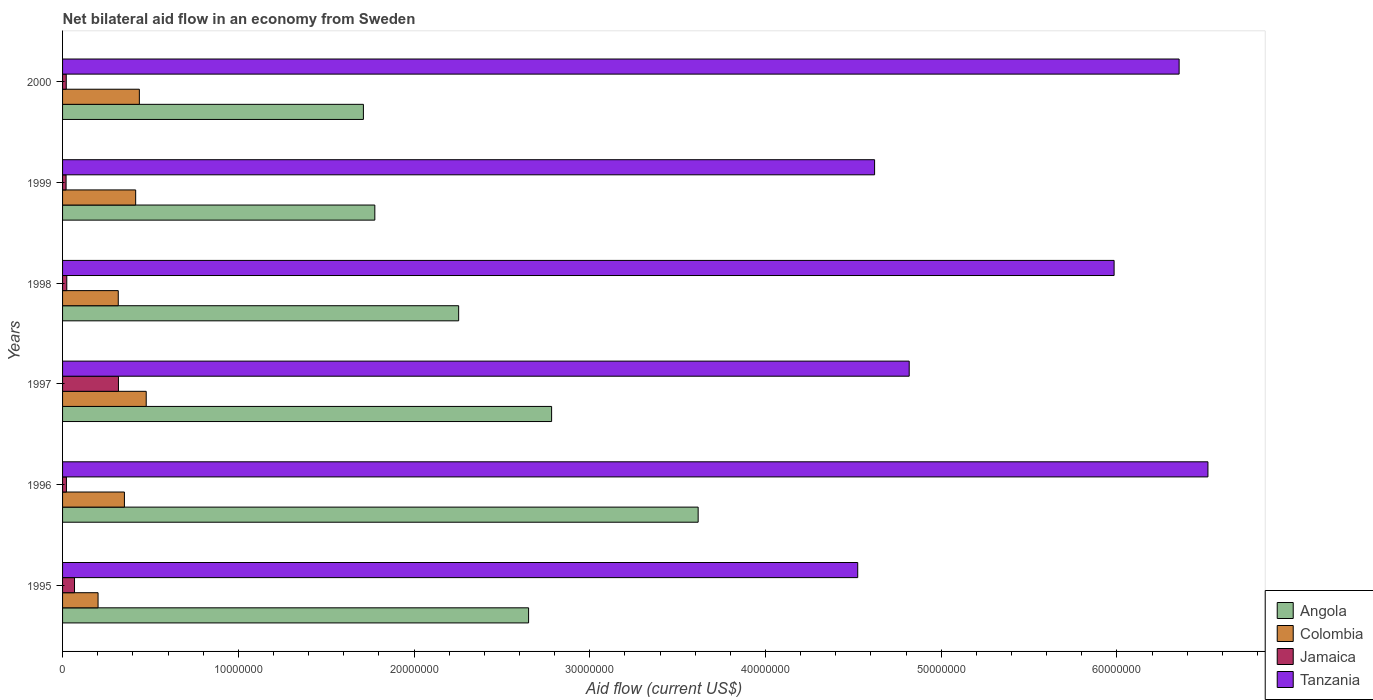Are the number of bars per tick equal to the number of legend labels?
Provide a succinct answer. Yes. Are the number of bars on each tick of the Y-axis equal?
Provide a succinct answer. Yes. What is the net bilateral aid flow in Angola in 2000?
Offer a terse response. 1.71e+07. Across all years, what is the maximum net bilateral aid flow in Angola?
Give a very brief answer. 3.62e+07. Across all years, what is the minimum net bilateral aid flow in Jamaica?
Offer a terse response. 2.00e+05. In which year was the net bilateral aid flow in Tanzania minimum?
Provide a short and direct response. 1995. What is the total net bilateral aid flow in Angola in the graph?
Make the answer very short. 1.48e+08. What is the difference between the net bilateral aid flow in Angola in 1996 and the net bilateral aid flow in Jamaica in 1997?
Give a very brief answer. 3.30e+07. What is the average net bilateral aid flow in Colombia per year?
Offer a very short reply. 3.67e+06. In the year 1997, what is the difference between the net bilateral aid flow in Tanzania and net bilateral aid flow in Angola?
Your response must be concise. 2.04e+07. What is the ratio of the net bilateral aid flow in Jamaica in 1995 to that in 1998?
Offer a very short reply. 2.83. What is the difference between the highest and the second highest net bilateral aid flow in Colombia?
Your answer should be compact. 3.90e+05. What is the difference between the highest and the lowest net bilateral aid flow in Colombia?
Keep it short and to the point. 2.74e+06. In how many years, is the net bilateral aid flow in Angola greater than the average net bilateral aid flow in Angola taken over all years?
Ensure brevity in your answer.  3. What does the 2nd bar from the bottom in 2000 represents?
Give a very brief answer. Colombia. How many years are there in the graph?
Your answer should be very brief. 6. What is the difference between two consecutive major ticks on the X-axis?
Keep it short and to the point. 1.00e+07. Are the values on the major ticks of X-axis written in scientific E-notation?
Give a very brief answer. No. Where does the legend appear in the graph?
Provide a short and direct response. Bottom right. How many legend labels are there?
Give a very brief answer. 4. What is the title of the graph?
Your answer should be compact. Net bilateral aid flow in an economy from Sweden. What is the label or title of the Y-axis?
Offer a very short reply. Years. What is the Aid flow (current US$) in Angola in 1995?
Keep it short and to the point. 2.65e+07. What is the Aid flow (current US$) of Colombia in 1995?
Offer a terse response. 2.02e+06. What is the Aid flow (current US$) of Jamaica in 1995?
Offer a terse response. 6.80e+05. What is the Aid flow (current US$) in Tanzania in 1995?
Provide a succinct answer. 4.52e+07. What is the Aid flow (current US$) in Angola in 1996?
Offer a terse response. 3.62e+07. What is the Aid flow (current US$) in Colombia in 1996?
Your response must be concise. 3.52e+06. What is the Aid flow (current US$) in Jamaica in 1996?
Offer a very short reply. 2.20e+05. What is the Aid flow (current US$) in Tanzania in 1996?
Ensure brevity in your answer.  6.52e+07. What is the Aid flow (current US$) in Angola in 1997?
Your answer should be very brief. 2.78e+07. What is the Aid flow (current US$) in Colombia in 1997?
Your answer should be compact. 4.76e+06. What is the Aid flow (current US$) in Jamaica in 1997?
Your answer should be compact. 3.18e+06. What is the Aid flow (current US$) of Tanzania in 1997?
Provide a succinct answer. 4.82e+07. What is the Aid flow (current US$) of Angola in 1998?
Offer a very short reply. 2.25e+07. What is the Aid flow (current US$) of Colombia in 1998?
Keep it short and to the point. 3.17e+06. What is the Aid flow (current US$) in Tanzania in 1998?
Make the answer very short. 5.98e+07. What is the Aid flow (current US$) in Angola in 1999?
Ensure brevity in your answer.  1.78e+07. What is the Aid flow (current US$) in Colombia in 1999?
Offer a very short reply. 4.16e+06. What is the Aid flow (current US$) in Tanzania in 1999?
Give a very brief answer. 4.62e+07. What is the Aid flow (current US$) of Angola in 2000?
Provide a short and direct response. 1.71e+07. What is the Aid flow (current US$) in Colombia in 2000?
Offer a terse response. 4.37e+06. What is the Aid flow (current US$) in Tanzania in 2000?
Offer a very short reply. 6.35e+07. Across all years, what is the maximum Aid flow (current US$) of Angola?
Make the answer very short. 3.62e+07. Across all years, what is the maximum Aid flow (current US$) of Colombia?
Keep it short and to the point. 4.76e+06. Across all years, what is the maximum Aid flow (current US$) of Jamaica?
Your response must be concise. 3.18e+06. Across all years, what is the maximum Aid flow (current US$) in Tanzania?
Your response must be concise. 6.52e+07. Across all years, what is the minimum Aid flow (current US$) in Angola?
Your response must be concise. 1.71e+07. Across all years, what is the minimum Aid flow (current US$) of Colombia?
Offer a very short reply. 2.02e+06. Across all years, what is the minimum Aid flow (current US$) of Tanzania?
Give a very brief answer. 4.52e+07. What is the total Aid flow (current US$) of Angola in the graph?
Provide a short and direct response. 1.48e+08. What is the total Aid flow (current US$) of Colombia in the graph?
Keep it short and to the point. 2.20e+07. What is the total Aid flow (current US$) in Jamaica in the graph?
Offer a terse response. 4.73e+06. What is the total Aid flow (current US$) in Tanzania in the graph?
Your answer should be compact. 3.28e+08. What is the difference between the Aid flow (current US$) of Angola in 1995 and that in 1996?
Offer a terse response. -9.65e+06. What is the difference between the Aid flow (current US$) of Colombia in 1995 and that in 1996?
Keep it short and to the point. -1.50e+06. What is the difference between the Aid flow (current US$) of Tanzania in 1995 and that in 1996?
Provide a short and direct response. -1.99e+07. What is the difference between the Aid flow (current US$) of Angola in 1995 and that in 1997?
Keep it short and to the point. -1.31e+06. What is the difference between the Aid flow (current US$) of Colombia in 1995 and that in 1997?
Keep it short and to the point. -2.74e+06. What is the difference between the Aid flow (current US$) in Jamaica in 1995 and that in 1997?
Your answer should be compact. -2.50e+06. What is the difference between the Aid flow (current US$) in Tanzania in 1995 and that in 1997?
Offer a terse response. -2.93e+06. What is the difference between the Aid flow (current US$) in Angola in 1995 and that in 1998?
Your response must be concise. 3.98e+06. What is the difference between the Aid flow (current US$) of Colombia in 1995 and that in 1998?
Ensure brevity in your answer.  -1.15e+06. What is the difference between the Aid flow (current US$) of Jamaica in 1995 and that in 1998?
Your answer should be compact. 4.40e+05. What is the difference between the Aid flow (current US$) in Tanzania in 1995 and that in 1998?
Provide a short and direct response. -1.46e+07. What is the difference between the Aid flow (current US$) in Angola in 1995 and that in 1999?
Provide a succinct answer. 8.75e+06. What is the difference between the Aid flow (current US$) in Colombia in 1995 and that in 1999?
Your answer should be compact. -2.14e+06. What is the difference between the Aid flow (current US$) in Jamaica in 1995 and that in 1999?
Your answer should be compact. 4.80e+05. What is the difference between the Aid flow (current US$) in Tanzania in 1995 and that in 1999?
Your answer should be compact. -9.60e+05. What is the difference between the Aid flow (current US$) in Angola in 1995 and that in 2000?
Offer a terse response. 9.40e+06. What is the difference between the Aid flow (current US$) in Colombia in 1995 and that in 2000?
Give a very brief answer. -2.35e+06. What is the difference between the Aid flow (current US$) in Jamaica in 1995 and that in 2000?
Keep it short and to the point. 4.70e+05. What is the difference between the Aid flow (current US$) of Tanzania in 1995 and that in 2000?
Make the answer very short. -1.83e+07. What is the difference between the Aid flow (current US$) of Angola in 1996 and that in 1997?
Your answer should be very brief. 8.34e+06. What is the difference between the Aid flow (current US$) in Colombia in 1996 and that in 1997?
Your answer should be compact. -1.24e+06. What is the difference between the Aid flow (current US$) of Jamaica in 1996 and that in 1997?
Provide a succinct answer. -2.96e+06. What is the difference between the Aid flow (current US$) of Tanzania in 1996 and that in 1997?
Provide a short and direct response. 1.70e+07. What is the difference between the Aid flow (current US$) in Angola in 1996 and that in 1998?
Make the answer very short. 1.36e+07. What is the difference between the Aid flow (current US$) of Colombia in 1996 and that in 1998?
Make the answer very short. 3.50e+05. What is the difference between the Aid flow (current US$) of Jamaica in 1996 and that in 1998?
Offer a very short reply. -2.00e+04. What is the difference between the Aid flow (current US$) of Tanzania in 1996 and that in 1998?
Make the answer very short. 5.34e+06. What is the difference between the Aid flow (current US$) of Angola in 1996 and that in 1999?
Provide a short and direct response. 1.84e+07. What is the difference between the Aid flow (current US$) of Colombia in 1996 and that in 1999?
Ensure brevity in your answer.  -6.40e+05. What is the difference between the Aid flow (current US$) of Tanzania in 1996 and that in 1999?
Provide a short and direct response. 1.90e+07. What is the difference between the Aid flow (current US$) of Angola in 1996 and that in 2000?
Make the answer very short. 1.90e+07. What is the difference between the Aid flow (current US$) of Colombia in 1996 and that in 2000?
Offer a terse response. -8.50e+05. What is the difference between the Aid flow (current US$) of Tanzania in 1996 and that in 2000?
Your response must be concise. 1.64e+06. What is the difference between the Aid flow (current US$) in Angola in 1997 and that in 1998?
Give a very brief answer. 5.29e+06. What is the difference between the Aid flow (current US$) in Colombia in 1997 and that in 1998?
Make the answer very short. 1.59e+06. What is the difference between the Aid flow (current US$) in Jamaica in 1997 and that in 1998?
Your answer should be compact. 2.94e+06. What is the difference between the Aid flow (current US$) in Tanzania in 1997 and that in 1998?
Your answer should be very brief. -1.17e+07. What is the difference between the Aid flow (current US$) in Angola in 1997 and that in 1999?
Keep it short and to the point. 1.01e+07. What is the difference between the Aid flow (current US$) of Jamaica in 1997 and that in 1999?
Keep it short and to the point. 2.98e+06. What is the difference between the Aid flow (current US$) in Tanzania in 1997 and that in 1999?
Your answer should be very brief. 1.97e+06. What is the difference between the Aid flow (current US$) of Angola in 1997 and that in 2000?
Keep it short and to the point. 1.07e+07. What is the difference between the Aid flow (current US$) in Jamaica in 1997 and that in 2000?
Offer a very short reply. 2.97e+06. What is the difference between the Aid flow (current US$) in Tanzania in 1997 and that in 2000?
Give a very brief answer. -1.54e+07. What is the difference between the Aid flow (current US$) of Angola in 1998 and that in 1999?
Your response must be concise. 4.77e+06. What is the difference between the Aid flow (current US$) of Colombia in 1998 and that in 1999?
Give a very brief answer. -9.90e+05. What is the difference between the Aid flow (current US$) in Tanzania in 1998 and that in 1999?
Keep it short and to the point. 1.36e+07. What is the difference between the Aid flow (current US$) of Angola in 1998 and that in 2000?
Provide a succinct answer. 5.42e+06. What is the difference between the Aid flow (current US$) of Colombia in 1998 and that in 2000?
Provide a short and direct response. -1.20e+06. What is the difference between the Aid flow (current US$) of Jamaica in 1998 and that in 2000?
Keep it short and to the point. 3.00e+04. What is the difference between the Aid flow (current US$) in Tanzania in 1998 and that in 2000?
Your response must be concise. -3.70e+06. What is the difference between the Aid flow (current US$) in Angola in 1999 and that in 2000?
Keep it short and to the point. 6.50e+05. What is the difference between the Aid flow (current US$) in Tanzania in 1999 and that in 2000?
Offer a very short reply. -1.73e+07. What is the difference between the Aid flow (current US$) of Angola in 1995 and the Aid flow (current US$) of Colombia in 1996?
Ensure brevity in your answer.  2.30e+07. What is the difference between the Aid flow (current US$) of Angola in 1995 and the Aid flow (current US$) of Jamaica in 1996?
Make the answer very short. 2.63e+07. What is the difference between the Aid flow (current US$) of Angola in 1995 and the Aid flow (current US$) of Tanzania in 1996?
Ensure brevity in your answer.  -3.87e+07. What is the difference between the Aid flow (current US$) of Colombia in 1995 and the Aid flow (current US$) of Jamaica in 1996?
Ensure brevity in your answer.  1.80e+06. What is the difference between the Aid flow (current US$) in Colombia in 1995 and the Aid flow (current US$) in Tanzania in 1996?
Provide a succinct answer. -6.32e+07. What is the difference between the Aid flow (current US$) of Jamaica in 1995 and the Aid flow (current US$) of Tanzania in 1996?
Your response must be concise. -6.45e+07. What is the difference between the Aid flow (current US$) of Angola in 1995 and the Aid flow (current US$) of Colombia in 1997?
Give a very brief answer. 2.18e+07. What is the difference between the Aid flow (current US$) of Angola in 1995 and the Aid flow (current US$) of Jamaica in 1997?
Offer a very short reply. 2.33e+07. What is the difference between the Aid flow (current US$) in Angola in 1995 and the Aid flow (current US$) in Tanzania in 1997?
Offer a very short reply. -2.17e+07. What is the difference between the Aid flow (current US$) in Colombia in 1995 and the Aid flow (current US$) in Jamaica in 1997?
Make the answer very short. -1.16e+06. What is the difference between the Aid flow (current US$) of Colombia in 1995 and the Aid flow (current US$) of Tanzania in 1997?
Ensure brevity in your answer.  -4.62e+07. What is the difference between the Aid flow (current US$) in Jamaica in 1995 and the Aid flow (current US$) in Tanzania in 1997?
Provide a succinct answer. -4.75e+07. What is the difference between the Aid flow (current US$) of Angola in 1995 and the Aid flow (current US$) of Colombia in 1998?
Provide a succinct answer. 2.34e+07. What is the difference between the Aid flow (current US$) of Angola in 1995 and the Aid flow (current US$) of Jamaica in 1998?
Ensure brevity in your answer.  2.63e+07. What is the difference between the Aid flow (current US$) in Angola in 1995 and the Aid flow (current US$) in Tanzania in 1998?
Keep it short and to the point. -3.33e+07. What is the difference between the Aid flow (current US$) in Colombia in 1995 and the Aid flow (current US$) in Jamaica in 1998?
Your answer should be very brief. 1.78e+06. What is the difference between the Aid flow (current US$) in Colombia in 1995 and the Aid flow (current US$) in Tanzania in 1998?
Give a very brief answer. -5.78e+07. What is the difference between the Aid flow (current US$) in Jamaica in 1995 and the Aid flow (current US$) in Tanzania in 1998?
Give a very brief answer. -5.92e+07. What is the difference between the Aid flow (current US$) in Angola in 1995 and the Aid flow (current US$) in Colombia in 1999?
Your answer should be very brief. 2.24e+07. What is the difference between the Aid flow (current US$) in Angola in 1995 and the Aid flow (current US$) in Jamaica in 1999?
Offer a very short reply. 2.63e+07. What is the difference between the Aid flow (current US$) in Angola in 1995 and the Aid flow (current US$) in Tanzania in 1999?
Your answer should be compact. -1.97e+07. What is the difference between the Aid flow (current US$) in Colombia in 1995 and the Aid flow (current US$) in Jamaica in 1999?
Your response must be concise. 1.82e+06. What is the difference between the Aid flow (current US$) in Colombia in 1995 and the Aid flow (current US$) in Tanzania in 1999?
Give a very brief answer. -4.42e+07. What is the difference between the Aid flow (current US$) of Jamaica in 1995 and the Aid flow (current US$) of Tanzania in 1999?
Give a very brief answer. -4.55e+07. What is the difference between the Aid flow (current US$) in Angola in 1995 and the Aid flow (current US$) in Colombia in 2000?
Make the answer very short. 2.22e+07. What is the difference between the Aid flow (current US$) in Angola in 1995 and the Aid flow (current US$) in Jamaica in 2000?
Give a very brief answer. 2.63e+07. What is the difference between the Aid flow (current US$) of Angola in 1995 and the Aid flow (current US$) of Tanzania in 2000?
Provide a short and direct response. -3.70e+07. What is the difference between the Aid flow (current US$) in Colombia in 1995 and the Aid flow (current US$) in Jamaica in 2000?
Keep it short and to the point. 1.81e+06. What is the difference between the Aid flow (current US$) of Colombia in 1995 and the Aid flow (current US$) of Tanzania in 2000?
Keep it short and to the point. -6.15e+07. What is the difference between the Aid flow (current US$) of Jamaica in 1995 and the Aid flow (current US$) of Tanzania in 2000?
Your answer should be compact. -6.29e+07. What is the difference between the Aid flow (current US$) of Angola in 1996 and the Aid flow (current US$) of Colombia in 1997?
Your answer should be very brief. 3.14e+07. What is the difference between the Aid flow (current US$) of Angola in 1996 and the Aid flow (current US$) of Jamaica in 1997?
Offer a terse response. 3.30e+07. What is the difference between the Aid flow (current US$) of Angola in 1996 and the Aid flow (current US$) of Tanzania in 1997?
Your answer should be very brief. -1.20e+07. What is the difference between the Aid flow (current US$) in Colombia in 1996 and the Aid flow (current US$) in Tanzania in 1997?
Your answer should be compact. -4.47e+07. What is the difference between the Aid flow (current US$) in Jamaica in 1996 and the Aid flow (current US$) in Tanzania in 1997?
Give a very brief answer. -4.80e+07. What is the difference between the Aid flow (current US$) in Angola in 1996 and the Aid flow (current US$) in Colombia in 1998?
Keep it short and to the point. 3.30e+07. What is the difference between the Aid flow (current US$) in Angola in 1996 and the Aid flow (current US$) in Jamaica in 1998?
Make the answer very short. 3.59e+07. What is the difference between the Aid flow (current US$) of Angola in 1996 and the Aid flow (current US$) of Tanzania in 1998?
Keep it short and to the point. -2.37e+07. What is the difference between the Aid flow (current US$) of Colombia in 1996 and the Aid flow (current US$) of Jamaica in 1998?
Offer a terse response. 3.28e+06. What is the difference between the Aid flow (current US$) in Colombia in 1996 and the Aid flow (current US$) in Tanzania in 1998?
Keep it short and to the point. -5.63e+07. What is the difference between the Aid flow (current US$) in Jamaica in 1996 and the Aid flow (current US$) in Tanzania in 1998?
Offer a very short reply. -5.96e+07. What is the difference between the Aid flow (current US$) of Angola in 1996 and the Aid flow (current US$) of Colombia in 1999?
Your response must be concise. 3.20e+07. What is the difference between the Aid flow (current US$) in Angola in 1996 and the Aid flow (current US$) in Jamaica in 1999?
Your response must be concise. 3.60e+07. What is the difference between the Aid flow (current US$) of Angola in 1996 and the Aid flow (current US$) of Tanzania in 1999?
Offer a terse response. -1.00e+07. What is the difference between the Aid flow (current US$) in Colombia in 1996 and the Aid flow (current US$) in Jamaica in 1999?
Your answer should be compact. 3.32e+06. What is the difference between the Aid flow (current US$) in Colombia in 1996 and the Aid flow (current US$) in Tanzania in 1999?
Keep it short and to the point. -4.27e+07. What is the difference between the Aid flow (current US$) of Jamaica in 1996 and the Aid flow (current US$) of Tanzania in 1999?
Offer a very short reply. -4.60e+07. What is the difference between the Aid flow (current US$) of Angola in 1996 and the Aid flow (current US$) of Colombia in 2000?
Provide a short and direct response. 3.18e+07. What is the difference between the Aid flow (current US$) in Angola in 1996 and the Aid flow (current US$) in Jamaica in 2000?
Ensure brevity in your answer.  3.60e+07. What is the difference between the Aid flow (current US$) of Angola in 1996 and the Aid flow (current US$) of Tanzania in 2000?
Provide a succinct answer. -2.74e+07. What is the difference between the Aid flow (current US$) of Colombia in 1996 and the Aid flow (current US$) of Jamaica in 2000?
Provide a succinct answer. 3.31e+06. What is the difference between the Aid flow (current US$) of Colombia in 1996 and the Aid flow (current US$) of Tanzania in 2000?
Your response must be concise. -6.00e+07. What is the difference between the Aid flow (current US$) of Jamaica in 1996 and the Aid flow (current US$) of Tanzania in 2000?
Offer a terse response. -6.33e+07. What is the difference between the Aid flow (current US$) of Angola in 1997 and the Aid flow (current US$) of Colombia in 1998?
Make the answer very short. 2.47e+07. What is the difference between the Aid flow (current US$) of Angola in 1997 and the Aid flow (current US$) of Jamaica in 1998?
Offer a terse response. 2.76e+07. What is the difference between the Aid flow (current US$) in Angola in 1997 and the Aid flow (current US$) in Tanzania in 1998?
Provide a short and direct response. -3.20e+07. What is the difference between the Aid flow (current US$) in Colombia in 1997 and the Aid flow (current US$) in Jamaica in 1998?
Make the answer very short. 4.52e+06. What is the difference between the Aid flow (current US$) of Colombia in 1997 and the Aid flow (current US$) of Tanzania in 1998?
Your response must be concise. -5.51e+07. What is the difference between the Aid flow (current US$) of Jamaica in 1997 and the Aid flow (current US$) of Tanzania in 1998?
Your answer should be compact. -5.67e+07. What is the difference between the Aid flow (current US$) in Angola in 1997 and the Aid flow (current US$) in Colombia in 1999?
Your answer should be very brief. 2.37e+07. What is the difference between the Aid flow (current US$) of Angola in 1997 and the Aid flow (current US$) of Jamaica in 1999?
Give a very brief answer. 2.76e+07. What is the difference between the Aid flow (current US$) of Angola in 1997 and the Aid flow (current US$) of Tanzania in 1999?
Offer a terse response. -1.84e+07. What is the difference between the Aid flow (current US$) in Colombia in 1997 and the Aid flow (current US$) in Jamaica in 1999?
Provide a succinct answer. 4.56e+06. What is the difference between the Aid flow (current US$) of Colombia in 1997 and the Aid flow (current US$) of Tanzania in 1999?
Provide a short and direct response. -4.14e+07. What is the difference between the Aid flow (current US$) in Jamaica in 1997 and the Aid flow (current US$) in Tanzania in 1999?
Your answer should be compact. -4.30e+07. What is the difference between the Aid flow (current US$) in Angola in 1997 and the Aid flow (current US$) in Colombia in 2000?
Provide a succinct answer. 2.35e+07. What is the difference between the Aid flow (current US$) of Angola in 1997 and the Aid flow (current US$) of Jamaica in 2000?
Your answer should be very brief. 2.76e+07. What is the difference between the Aid flow (current US$) of Angola in 1997 and the Aid flow (current US$) of Tanzania in 2000?
Make the answer very short. -3.57e+07. What is the difference between the Aid flow (current US$) of Colombia in 1997 and the Aid flow (current US$) of Jamaica in 2000?
Your response must be concise. 4.55e+06. What is the difference between the Aid flow (current US$) in Colombia in 1997 and the Aid flow (current US$) in Tanzania in 2000?
Give a very brief answer. -5.88e+07. What is the difference between the Aid flow (current US$) in Jamaica in 1997 and the Aid flow (current US$) in Tanzania in 2000?
Provide a short and direct response. -6.04e+07. What is the difference between the Aid flow (current US$) in Angola in 1998 and the Aid flow (current US$) in Colombia in 1999?
Your response must be concise. 1.84e+07. What is the difference between the Aid flow (current US$) in Angola in 1998 and the Aid flow (current US$) in Jamaica in 1999?
Make the answer very short. 2.23e+07. What is the difference between the Aid flow (current US$) in Angola in 1998 and the Aid flow (current US$) in Tanzania in 1999?
Make the answer very short. -2.37e+07. What is the difference between the Aid flow (current US$) in Colombia in 1998 and the Aid flow (current US$) in Jamaica in 1999?
Your answer should be very brief. 2.97e+06. What is the difference between the Aid flow (current US$) in Colombia in 1998 and the Aid flow (current US$) in Tanzania in 1999?
Your response must be concise. -4.30e+07. What is the difference between the Aid flow (current US$) of Jamaica in 1998 and the Aid flow (current US$) of Tanzania in 1999?
Offer a very short reply. -4.60e+07. What is the difference between the Aid flow (current US$) in Angola in 1998 and the Aid flow (current US$) in Colombia in 2000?
Offer a terse response. 1.82e+07. What is the difference between the Aid flow (current US$) of Angola in 1998 and the Aid flow (current US$) of Jamaica in 2000?
Ensure brevity in your answer.  2.23e+07. What is the difference between the Aid flow (current US$) in Angola in 1998 and the Aid flow (current US$) in Tanzania in 2000?
Offer a very short reply. -4.10e+07. What is the difference between the Aid flow (current US$) in Colombia in 1998 and the Aid flow (current US$) in Jamaica in 2000?
Keep it short and to the point. 2.96e+06. What is the difference between the Aid flow (current US$) in Colombia in 1998 and the Aid flow (current US$) in Tanzania in 2000?
Provide a short and direct response. -6.04e+07. What is the difference between the Aid flow (current US$) of Jamaica in 1998 and the Aid flow (current US$) of Tanzania in 2000?
Ensure brevity in your answer.  -6.33e+07. What is the difference between the Aid flow (current US$) in Angola in 1999 and the Aid flow (current US$) in Colombia in 2000?
Give a very brief answer. 1.34e+07. What is the difference between the Aid flow (current US$) in Angola in 1999 and the Aid flow (current US$) in Jamaica in 2000?
Your answer should be compact. 1.76e+07. What is the difference between the Aid flow (current US$) in Angola in 1999 and the Aid flow (current US$) in Tanzania in 2000?
Your response must be concise. -4.58e+07. What is the difference between the Aid flow (current US$) of Colombia in 1999 and the Aid flow (current US$) of Jamaica in 2000?
Your response must be concise. 3.95e+06. What is the difference between the Aid flow (current US$) of Colombia in 1999 and the Aid flow (current US$) of Tanzania in 2000?
Ensure brevity in your answer.  -5.94e+07. What is the difference between the Aid flow (current US$) in Jamaica in 1999 and the Aid flow (current US$) in Tanzania in 2000?
Your answer should be compact. -6.33e+07. What is the average Aid flow (current US$) in Angola per year?
Keep it short and to the point. 2.47e+07. What is the average Aid flow (current US$) of Colombia per year?
Your answer should be very brief. 3.67e+06. What is the average Aid flow (current US$) of Jamaica per year?
Offer a terse response. 7.88e+05. What is the average Aid flow (current US$) of Tanzania per year?
Offer a terse response. 5.47e+07. In the year 1995, what is the difference between the Aid flow (current US$) of Angola and Aid flow (current US$) of Colombia?
Your response must be concise. 2.45e+07. In the year 1995, what is the difference between the Aid flow (current US$) of Angola and Aid flow (current US$) of Jamaica?
Your answer should be very brief. 2.58e+07. In the year 1995, what is the difference between the Aid flow (current US$) in Angola and Aid flow (current US$) in Tanzania?
Give a very brief answer. -1.87e+07. In the year 1995, what is the difference between the Aid flow (current US$) of Colombia and Aid flow (current US$) of Jamaica?
Provide a succinct answer. 1.34e+06. In the year 1995, what is the difference between the Aid flow (current US$) in Colombia and Aid flow (current US$) in Tanzania?
Keep it short and to the point. -4.32e+07. In the year 1995, what is the difference between the Aid flow (current US$) in Jamaica and Aid flow (current US$) in Tanzania?
Your response must be concise. -4.46e+07. In the year 1996, what is the difference between the Aid flow (current US$) in Angola and Aid flow (current US$) in Colombia?
Offer a terse response. 3.26e+07. In the year 1996, what is the difference between the Aid flow (current US$) of Angola and Aid flow (current US$) of Jamaica?
Ensure brevity in your answer.  3.60e+07. In the year 1996, what is the difference between the Aid flow (current US$) of Angola and Aid flow (current US$) of Tanzania?
Give a very brief answer. -2.90e+07. In the year 1996, what is the difference between the Aid flow (current US$) in Colombia and Aid flow (current US$) in Jamaica?
Keep it short and to the point. 3.30e+06. In the year 1996, what is the difference between the Aid flow (current US$) in Colombia and Aid flow (current US$) in Tanzania?
Make the answer very short. -6.17e+07. In the year 1996, what is the difference between the Aid flow (current US$) of Jamaica and Aid flow (current US$) of Tanzania?
Make the answer very short. -6.50e+07. In the year 1997, what is the difference between the Aid flow (current US$) of Angola and Aid flow (current US$) of Colombia?
Give a very brief answer. 2.31e+07. In the year 1997, what is the difference between the Aid flow (current US$) in Angola and Aid flow (current US$) in Jamaica?
Your answer should be compact. 2.46e+07. In the year 1997, what is the difference between the Aid flow (current US$) of Angola and Aid flow (current US$) of Tanzania?
Provide a succinct answer. -2.04e+07. In the year 1997, what is the difference between the Aid flow (current US$) of Colombia and Aid flow (current US$) of Jamaica?
Your response must be concise. 1.58e+06. In the year 1997, what is the difference between the Aid flow (current US$) of Colombia and Aid flow (current US$) of Tanzania?
Your response must be concise. -4.34e+07. In the year 1997, what is the difference between the Aid flow (current US$) in Jamaica and Aid flow (current US$) in Tanzania?
Make the answer very short. -4.50e+07. In the year 1998, what is the difference between the Aid flow (current US$) in Angola and Aid flow (current US$) in Colombia?
Make the answer very short. 1.94e+07. In the year 1998, what is the difference between the Aid flow (current US$) of Angola and Aid flow (current US$) of Jamaica?
Your answer should be very brief. 2.23e+07. In the year 1998, what is the difference between the Aid flow (current US$) in Angola and Aid flow (current US$) in Tanzania?
Make the answer very short. -3.73e+07. In the year 1998, what is the difference between the Aid flow (current US$) in Colombia and Aid flow (current US$) in Jamaica?
Keep it short and to the point. 2.93e+06. In the year 1998, what is the difference between the Aid flow (current US$) of Colombia and Aid flow (current US$) of Tanzania?
Provide a short and direct response. -5.67e+07. In the year 1998, what is the difference between the Aid flow (current US$) in Jamaica and Aid flow (current US$) in Tanzania?
Offer a very short reply. -5.96e+07. In the year 1999, what is the difference between the Aid flow (current US$) in Angola and Aid flow (current US$) in Colombia?
Your response must be concise. 1.36e+07. In the year 1999, what is the difference between the Aid flow (current US$) in Angola and Aid flow (current US$) in Jamaica?
Your answer should be compact. 1.76e+07. In the year 1999, what is the difference between the Aid flow (current US$) of Angola and Aid flow (current US$) of Tanzania?
Keep it short and to the point. -2.84e+07. In the year 1999, what is the difference between the Aid flow (current US$) of Colombia and Aid flow (current US$) of Jamaica?
Keep it short and to the point. 3.96e+06. In the year 1999, what is the difference between the Aid flow (current US$) in Colombia and Aid flow (current US$) in Tanzania?
Provide a short and direct response. -4.20e+07. In the year 1999, what is the difference between the Aid flow (current US$) in Jamaica and Aid flow (current US$) in Tanzania?
Keep it short and to the point. -4.60e+07. In the year 2000, what is the difference between the Aid flow (current US$) in Angola and Aid flow (current US$) in Colombia?
Your response must be concise. 1.28e+07. In the year 2000, what is the difference between the Aid flow (current US$) in Angola and Aid flow (current US$) in Jamaica?
Give a very brief answer. 1.69e+07. In the year 2000, what is the difference between the Aid flow (current US$) in Angola and Aid flow (current US$) in Tanzania?
Provide a short and direct response. -4.64e+07. In the year 2000, what is the difference between the Aid flow (current US$) in Colombia and Aid flow (current US$) in Jamaica?
Ensure brevity in your answer.  4.16e+06. In the year 2000, what is the difference between the Aid flow (current US$) of Colombia and Aid flow (current US$) of Tanzania?
Your answer should be compact. -5.92e+07. In the year 2000, what is the difference between the Aid flow (current US$) of Jamaica and Aid flow (current US$) of Tanzania?
Provide a short and direct response. -6.33e+07. What is the ratio of the Aid flow (current US$) of Angola in 1995 to that in 1996?
Your answer should be very brief. 0.73. What is the ratio of the Aid flow (current US$) of Colombia in 1995 to that in 1996?
Offer a very short reply. 0.57. What is the ratio of the Aid flow (current US$) of Jamaica in 1995 to that in 1996?
Provide a short and direct response. 3.09. What is the ratio of the Aid flow (current US$) in Tanzania in 1995 to that in 1996?
Offer a very short reply. 0.69. What is the ratio of the Aid flow (current US$) of Angola in 1995 to that in 1997?
Provide a succinct answer. 0.95. What is the ratio of the Aid flow (current US$) in Colombia in 1995 to that in 1997?
Offer a terse response. 0.42. What is the ratio of the Aid flow (current US$) of Jamaica in 1995 to that in 1997?
Offer a terse response. 0.21. What is the ratio of the Aid flow (current US$) of Tanzania in 1995 to that in 1997?
Provide a succinct answer. 0.94. What is the ratio of the Aid flow (current US$) in Angola in 1995 to that in 1998?
Keep it short and to the point. 1.18. What is the ratio of the Aid flow (current US$) in Colombia in 1995 to that in 1998?
Make the answer very short. 0.64. What is the ratio of the Aid flow (current US$) of Jamaica in 1995 to that in 1998?
Your answer should be very brief. 2.83. What is the ratio of the Aid flow (current US$) in Tanzania in 1995 to that in 1998?
Your response must be concise. 0.76. What is the ratio of the Aid flow (current US$) in Angola in 1995 to that in 1999?
Your response must be concise. 1.49. What is the ratio of the Aid flow (current US$) of Colombia in 1995 to that in 1999?
Give a very brief answer. 0.49. What is the ratio of the Aid flow (current US$) in Tanzania in 1995 to that in 1999?
Your answer should be very brief. 0.98. What is the ratio of the Aid flow (current US$) of Angola in 1995 to that in 2000?
Ensure brevity in your answer.  1.55. What is the ratio of the Aid flow (current US$) in Colombia in 1995 to that in 2000?
Provide a succinct answer. 0.46. What is the ratio of the Aid flow (current US$) in Jamaica in 1995 to that in 2000?
Provide a short and direct response. 3.24. What is the ratio of the Aid flow (current US$) of Tanzania in 1995 to that in 2000?
Offer a very short reply. 0.71. What is the ratio of the Aid flow (current US$) in Angola in 1996 to that in 1997?
Your answer should be compact. 1.3. What is the ratio of the Aid flow (current US$) in Colombia in 1996 to that in 1997?
Provide a short and direct response. 0.74. What is the ratio of the Aid flow (current US$) of Jamaica in 1996 to that in 1997?
Your answer should be compact. 0.07. What is the ratio of the Aid flow (current US$) of Tanzania in 1996 to that in 1997?
Your answer should be compact. 1.35. What is the ratio of the Aid flow (current US$) in Angola in 1996 to that in 1998?
Offer a very short reply. 1.6. What is the ratio of the Aid flow (current US$) in Colombia in 1996 to that in 1998?
Offer a terse response. 1.11. What is the ratio of the Aid flow (current US$) in Tanzania in 1996 to that in 1998?
Your answer should be very brief. 1.09. What is the ratio of the Aid flow (current US$) in Angola in 1996 to that in 1999?
Ensure brevity in your answer.  2.04. What is the ratio of the Aid flow (current US$) of Colombia in 1996 to that in 1999?
Your answer should be compact. 0.85. What is the ratio of the Aid flow (current US$) of Tanzania in 1996 to that in 1999?
Make the answer very short. 1.41. What is the ratio of the Aid flow (current US$) of Angola in 1996 to that in 2000?
Keep it short and to the point. 2.11. What is the ratio of the Aid flow (current US$) in Colombia in 1996 to that in 2000?
Provide a succinct answer. 0.81. What is the ratio of the Aid flow (current US$) of Jamaica in 1996 to that in 2000?
Offer a terse response. 1.05. What is the ratio of the Aid flow (current US$) in Tanzania in 1996 to that in 2000?
Your answer should be compact. 1.03. What is the ratio of the Aid flow (current US$) of Angola in 1997 to that in 1998?
Make the answer very short. 1.23. What is the ratio of the Aid flow (current US$) in Colombia in 1997 to that in 1998?
Offer a very short reply. 1.5. What is the ratio of the Aid flow (current US$) of Jamaica in 1997 to that in 1998?
Your answer should be compact. 13.25. What is the ratio of the Aid flow (current US$) of Tanzania in 1997 to that in 1998?
Offer a terse response. 0.81. What is the ratio of the Aid flow (current US$) in Angola in 1997 to that in 1999?
Ensure brevity in your answer.  1.57. What is the ratio of the Aid flow (current US$) of Colombia in 1997 to that in 1999?
Your answer should be compact. 1.14. What is the ratio of the Aid flow (current US$) of Tanzania in 1997 to that in 1999?
Your answer should be very brief. 1.04. What is the ratio of the Aid flow (current US$) in Angola in 1997 to that in 2000?
Give a very brief answer. 1.63. What is the ratio of the Aid flow (current US$) of Colombia in 1997 to that in 2000?
Make the answer very short. 1.09. What is the ratio of the Aid flow (current US$) of Jamaica in 1997 to that in 2000?
Make the answer very short. 15.14. What is the ratio of the Aid flow (current US$) in Tanzania in 1997 to that in 2000?
Your answer should be very brief. 0.76. What is the ratio of the Aid flow (current US$) of Angola in 1998 to that in 1999?
Offer a terse response. 1.27. What is the ratio of the Aid flow (current US$) of Colombia in 1998 to that in 1999?
Your answer should be compact. 0.76. What is the ratio of the Aid flow (current US$) of Tanzania in 1998 to that in 1999?
Give a very brief answer. 1.29. What is the ratio of the Aid flow (current US$) in Angola in 1998 to that in 2000?
Ensure brevity in your answer.  1.32. What is the ratio of the Aid flow (current US$) of Colombia in 1998 to that in 2000?
Ensure brevity in your answer.  0.73. What is the ratio of the Aid flow (current US$) of Tanzania in 1998 to that in 2000?
Your response must be concise. 0.94. What is the ratio of the Aid flow (current US$) in Angola in 1999 to that in 2000?
Your response must be concise. 1.04. What is the ratio of the Aid flow (current US$) of Colombia in 1999 to that in 2000?
Your answer should be compact. 0.95. What is the ratio of the Aid flow (current US$) in Tanzania in 1999 to that in 2000?
Make the answer very short. 0.73. What is the difference between the highest and the second highest Aid flow (current US$) in Angola?
Offer a terse response. 8.34e+06. What is the difference between the highest and the second highest Aid flow (current US$) in Jamaica?
Keep it short and to the point. 2.50e+06. What is the difference between the highest and the second highest Aid flow (current US$) in Tanzania?
Keep it short and to the point. 1.64e+06. What is the difference between the highest and the lowest Aid flow (current US$) of Angola?
Keep it short and to the point. 1.90e+07. What is the difference between the highest and the lowest Aid flow (current US$) in Colombia?
Provide a succinct answer. 2.74e+06. What is the difference between the highest and the lowest Aid flow (current US$) in Jamaica?
Provide a short and direct response. 2.98e+06. What is the difference between the highest and the lowest Aid flow (current US$) of Tanzania?
Your answer should be very brief. 1.99e+07. 